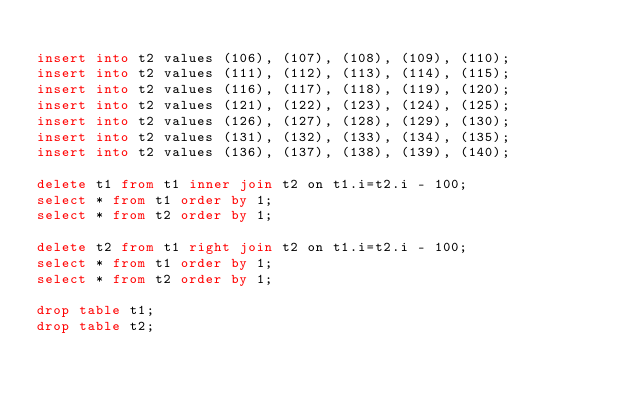Convert code to text. <code><loc_0><loc_0><loc_500><loc_500><_SQL_>
insert into t2 values (106), (107), (108), (109), (110);
insert into t2 values (111), (112), (113), (114), (115);
insert into t2 values (116), (117), (118), (119), (120);
insert into t2 values (121), (122), (123), (124), (125);
insert into t2 values (126), (127), (128), (129), (130);
insert into t2 values (131), (132), (133), (134), (135);
insert into t2 values (136), (137), (138), (139), (140);

delete t1 from t1 inner join t2 on t1.i=t2.i - 100;
select * from t1 order by 1;
select * from t2 order by 1;

delete t2 from t1 right join t2 on t1.i=t2.i - 100;
select * from t1 order by 1;
select * from t2 order by 1;

drop table t1;
drop table t2;</code> 